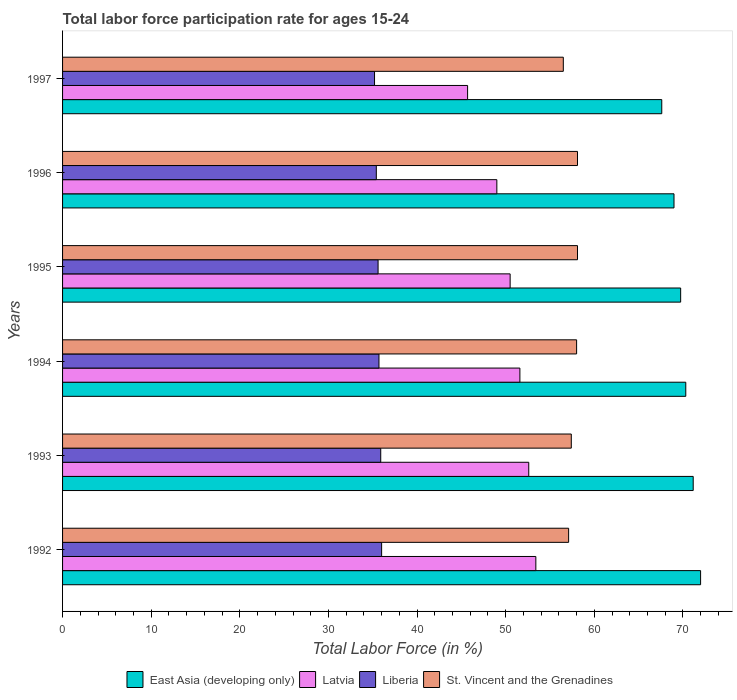How many different coloured bars are there?
Offer a very short reply. 4. How many groups of bars are there?
Keep it short and to the point. 6. Are the number of bars on each tick of the Y-axis equal?
Provide a succinct answer. Yes. What is the labor force participation rate in Liberia in 1994?
Provide a succinct answer. 35.7. Across all years, what is the maximum labor force participation rate in Latvia?
Give a very brief answer. 53.4. Across all years, what is the minimum labor force participation rate in Liberia?
Give a very brief answer. 35.2. In which year was the labor force participation rate in Latvia maximum?
Ensure brevity in your answer.  1992. In which year was the labor force participation rate in Liberia minimum?
Keep it short and to the point. 1997. What is the total labor force participation rate in East Asia (developing only) in the graph?
Keep it short and to the point. 419.8. What is the difference between the labor force participation rate in Latvia in 1994 and that in 1996?
Make the answer very short. 2.6. What is the average labor force participation rate in East Asia (developing only) per year?
Provide a succinct answer. 69.97. In the year 1994, what is the difference between the labor force participation rate in Latvia and labor force participation rate in East Asia (developing only)?
Provide a short and direct response. -18.72. What is the ratio of the labor force participation rate in Liberia in 1993 to that in 1995?
Your response must be concise. 1.01. Is the labor force participation rate in Latvia in 1994 less than that in 1995?
Give a very brief answer. No. Is the difference between the labor force participation rate in Latvia in 1992 and 1996 greater than the difference between the labor force participation rate in East Asia (developing only) in 1992 and 1996?
Keep it short and to the point. Yes. What is the difference between the highest and the second highest labor force participation rate in St. Vincent and the Grenadines?
Your answer should be very brief. 0. What is the difference between the highest and the lowest labor force participation rate in St. Vincent and the Grenadines?
Provide a short and direct response. 1.6. In how many years, is the labor force participation rate in Liberia greater than the average labor force participation rate in Liberia taken over all years?
Your answer should be very brief. 3. Is the sum of the labor force participation rate in Liberia in 1996 and 1997 greater than the maximum labor force participation rate in Latvia across all years?
Give a very brief answer. Yes. What does the 4th bar from the top in 1992 represents?
Give a very brief answer. East Asia (developing only). What does the 3rd bar from the bottom in 1997 represents?
Your response must be concise. Liberia. Is it the case that in every year, the sum of the labor force participation rate in Liberia and labor force participation rate in St. Vincent and the Grenadines is greater than the labor force participation rate in East Asia (developing only)?
Offer a terse response. Yes. How many years are there in the graph?
Your response must be concise. 6. What is the difference between two consecutive major ticks on the X-axis?
Your answer should be compact. 10. Are the values on the major ticks of X-axis written in scientific E-notation?
Make the answer very short. No. Does the graph contain grids?
Your answer should be compact. No. Where does the legend appear in the graph?
Your answer should be very brief. Bottom center. How are the legend labels stacked?
Give a very brief answer. Horizontal. What is the title of the graph?
Ensure brevity in your answer.  Total labor force participation rate for ages 15-24. Does "Bahrain" appear as one of the legend labels in the graph?
Ensure brevity in your answer.  No. What is the label or title of the X-axis?
Your response must be concise. Total Labor Force (in %). What is the Total Labor Force (in %) in East Asia (developing only) in 1992?
Ensure brevity in your answer.  71.99. What is the Total Labor Force (in %) in Latvia in 1992?
Provide a succinct answer. 53.4. What is the Total Labor Force (in %) in Liberia in 1992?
Your response must be concise. 36. What is the Total Labor Force (in %) of St. Vincent and the Grenadines in 1992?
Provide a short and direct response. 57.1. What is the Total Labor Force (in %) in East Asia (developing only) in 1993?
Your answer should be very brief. 71.16. What is the Total Labor Force (in %) in Latvia in 1993?
Your answer should be compact. 52.6. What is the Total Labor Force (in %) of Liberia in 1993?
Your answer should be very brief. 35.9. What is the Total Labor Force (in %) in St. Vincent and the Grenadines in 1993?
Ensure brevity in your answer.  57.4. What is the Total Labor Force (in %) in East Asia (developing only) in 1994?
Make the answer very short. 70.32. What is the Total Labor Force (in %) in Latvia in 1994?
Your response must be concise. 51.6. What is the Total Labor Force (in %) of Liberia in 1994?
Provide a succinct answer. 35.7. What is the Total Labor Force (in %) of St. Vincent and the Grenadines in 1994?
Provide a short and direct response. 58. What is the Total Labor Force (in %) in East Asia (developing only) in 1995?
Your answer should be very brief. 69.74. What is the Total Labor Force (in %) of Latvia in 1995?
Keep it short and to the point. 50.5. What is the Total Labor Force (in %) in Liberia in 1995?
Your response must be concise. 35.6. What is the Total Labor Force (in %) in St. Vincent and the Grenadines in 1995?
Provide a short and direct response. 58.1. What is the Total Labor Force (in %) in East Asia (developing only) in 1996?
Ensure brevity in your answer.  68.99. What is the Total Labor Force (in %) of Liberia in 1996?
Make the answer very short. 35.4. What is the Total Labor Force (in %) in St. Vincent and the Grenadines in 1996?
Make the answer very short. 58.1. What is the Total Labor Force (in %) in East Asia (developing only) in 1997?
Offer a terse response. 67.61. What is the Total Labor Force (in %) of Latvia in 1997?
Make the answer very short. 45.7. What is the Total Labor Force (in %) in Liberia in 1997?
Your answer should be compact. 35.2. What is the Total Labor Force (in %) of St. Vincent and the Grenadines in 1997?
Your answer should be very brief. 56.5. Across all years, what is the maximum Total Labor Force (in %) in East Asia (developing only)?
Provide a short and direct response. 71.99. Across all years, what is the maximum Total Labor Force (in %) of Latvia?
Ensure brevity in your answer.  53.4. Across all years, what is the maximum Total Labor Force (in %) in Liberia?
Your response must be concise. 36. Across all years, what is the maximum Total Labor Force (in %) of St. Vincent and the Grenadines?
Provide a short and direct response. 58.1. Across all years, what is the minimum Total Labor Force (in %) in East Asia (developing only)?
Ensure brevity in your answer.  67.61. Across all years, what is the minimum Total Labor Force (in %) of Latvia?
Your answer should be very brief. 45.7. Across all years, what is the minimum Total Labor Force (in %) of Liberia?
Keep it short and to the point. 35.2. Across all years, what is the minimum Total Labor Force (in %) of St. Vincent and the Grenadines?
Provide a short and direct response. 56.5. What is the total Total Labor Force (in %) in East Asia (developing only) in the graph?
Your answer should be very brief. 419.8. What is the total Total Labor Force (in %) of Latvia in the graph?
Provide a succinct answer. 302.8. What is the total Total Labor Force (in %) of Liberia in the graph?
Offer a terse response. 213.8. What is the total Total Labor Force (in %) of St. Vincent and the Grenadines in the graph?
Give a very brief answer. 345.2. What is the difference between the Total Labor Force (in %) of East Asia (developing only) in 1992 and that in 1993?
Give a very brief answer. 0.83. What is the difference between the Total Labor Force (in %) of Latvia in 1992 and that in 1993?
Offer a terse response. 0.8. What is the difference between the Total Labor Force (in %) of Liberia in 1992 and that in 1993?
Offer a terse response. 0.1. What is the difference between the Total Labor Force (in %) in St. Vincent and the Grenadines in 1992 and that in 1993?
Provide a succinct answer. -0.3. What is the difference between the Total Labor Force (in %) of East Asia (developing only) in 1992 and that in 1994?
Your response must be concise. 1.67. What is the difference between the Total Labor Force (in %) of Liberia in 1992 and that in 1994?
Offer a very short reply. 0.3. What is the difference between the Total Labor Force (in %) in East Asia (developing only) in 1992 and that in 1995?
Provide a short and direct response. 2.25. What is the difference between the Total Labor Force (in %) of Latvia in 1992 and that in 1995?
Keep it short and to the point. 2.9. What is the difference between the Total Labor Force (in %) of East Asia (developing only) in 1992 and that in 1996?
Your answer should be very brief. 3. What is the difference between the Total Labor Force (in %) in Latvia in 1992 and that in 1996?
Your answer should be compact. 4.4. What is the difference between the Total Labor Force (in %) in Liberia in 1992 and that in 1996?
Your response must be concise. 0.6. What is the difference between the Total Labor Force (in %) of St. Vincent and the Grenadines in 1992 and that in 1996?
Provide a short and direct response. -1. What is the difference between the Total Labor Force (in %) in East Asia (developing only) in 1992 and that in 1997?
Provide a short and direct response. 4.38. What is the difference between the Total Labor Force (in %) of East Asia (developing only) in 1993 and that in 1994?
Your answer should be compact. 0.84. What is the difference between the Total Labor Force (in %) of Latvia in 1993 and that in 1994?
Make the answer very short. 1. What is the difference between the Total Labor Force (in %) of Liberia in 1993 and that in 1994?
Provide a short and direct response. 0.2. What is the difference between the Total Labor Force (in %) of East Asia (developing only) in 1993 and that in 1995?
Make the answer very short. 1.42. What is the difference between the Total Labor Force (in %) in Liberia in 1993 and that in 1995?
Offer a very short reply. 0.3. What is the difference between the Total Labor Force (in %) in East Asia (developing only) in 1993 and that in 1996?
Make the answer very short. 2.17. What is the difference between the Total Labor Force (in %) in East Asia (developing only) in 1993 and that in 1997?
Your answer should be very brief. 3.55. What is the difference between the Total Labor Force (in %) in Latvia in 1993 and that in 1997?
Offer a very short reply. 6.9. What is the difference between the Total Labor Force (in %) of East Asia (developing only) in 1994 and that in 1995?
Your answer should be compact. 0.58. What is the difference between the Total Labor Force (in %) in East Asia (developing only) in 1994 and that in 1996?
Provide a short and direct response. 1.33. What is the difference between the Total Labor Force (in %) in Latvia in 1994 and that in 1996?
Provide a succinct answer. 2.6. What is the difference between the Total Labor Force (in %) in Liberia in 1994 and that in 1996?
Your answer should be very brief. 0.3. What is the difference between the Total Labor Force (in %) in East Asia (developing only) in 1994 and that in 1997?
Your answer should be very brief. 2.71. What is the difference between the Total Labor Force (in %) of Latvia in 1994 and that in 1997?
Your answer should be very brief. 5.9. What is the difference between the Total Labor Force (in %) in Liberia in 1994 and that in 1997?
Provide a succinct answer. 0.5. What is the difference between the Total Labor Force (in %) of St. Vincent and the Grenadines in 1994 and that in 1997?
Offer a very short reply. 1.5. What is the difference between the Total Labor Force (in %) of East Asia (developing only) in 1995 and that in 1996?
Your answer should be compact. 0.75. What is the difference between the Total Labor Force (in %) in Liberia in 1995 and that in 1996?
Your answer should be very brief. 0.2. What is the difference between the Total Labor Force (in %) of St. Vincent and the Grenadines in 1995 and that in 1996?
Provide a short and direct response. 0. What is the difference between the Total Labor Force (in %) in East Asia (developing only) in 1995 and that in 1997?
Provide a succinct answer. 2.13. What is the difference between the Total Labor Force (in %) of Liberia in 1995 and that in 1997?
Your response must be concise. 0.4. What is the difference between the Total Labor Force (in %) in East Asia (developing only) in 1996 and that in 1997?
Ensure brevity in your answer.  1.38. What is the difference between the Total Labor Force (in %) of Latvia in 1996 and that in 1997?
Ensure brevity in your answer.  3.3. What is the difference between the Total Labor Force (in %) in St. Vincent and the Grenadines in 1996 and that in 1997?
Make the answer very short. 1.6. What is the difference between the Total Labor Force (in %) of East Asia (developing only) in 1992 and the Total Labor Force (in %) of Latvia in 1993?
Your response must be concise. 19.39. What is the difference between the Total Labor Force (in %) in East Asia (developing only) in 1992 and the Total Labor Force (in %) in Liberia in 1993?
Keep it short and to the point. 36.09. What is the difference between the Total Labor Force (in %) in East Asia (developing only) in 1992 and the Total Labor Force (in %) in St. Vincent and the Grenadines in 1993?
Provide a succinct answer. 14.59. What is the difference between the Total Labor Force (in %) of Liberia in 1992 and the Total Labor Force (in %) of St. Vincent and the Grenadines in 1993?
Give a very brief answer. -21.4. What is the difference between the Total Labor Force (in %) in East Asia (developing only) in 1992 and the Total Labor Force (in %) in Latvia in 1994?
Provide a short and direct response. 20.39. What is the difference between the Total Labor Force (in %) in East Asia (developing only) in 1992 and the Total Labor Force (in %) in Liberia in 1994?
Your answer should be compact. 36.29. What is the difference between the Total Labor Force (in %) of East Asia (developing only) in 1992 and the Total Labor Force (in %) of St. Vincent and the Grenadines in 1994?
Ensure brevity in your answer.  13.99. What is the difference between the Total Labor Force (in %) in Latvia in 1992 and the Total Labor Force (in %) in Liberia in 1994?
Give a very brief answer. 17.7. What is the difference between the Total Labor Force (in %) of Latvia in 1992 and the Total Labor Force (in %) of St. Vincent and the Grenadines in 1994?
Keep it short and to the point. -4.6. What is the difference between the Total Labor Force (in %) in Liberia in 1992 and the Total Labor Force (in %) in St. Vincent and the Grenadines in 1994?
Your answer should be very brief. -22. What is the difference between the Total Labor Force (in %) of East Asia (developing only) in 1992 and the Total Labor Force (in %) of Latvia in 1995?
Give a very brief answer. 21.49. What is the difference between the Total Labor Force (in %) in East Asia (developing only) in 1992 and the Total Labor Force (in %) in Liberia in 1995?
Provide a succinct answer. 36.39. What is the difference between the Total Labor Force (in %) of East Asia (developing only) in 1992 and the Total Labor Force (in %) of St. Vincent and the Grenadines in 1995?
Offer a very short reply. 13.89. What is the difference between the Total Labor Force (in %) of Liberia in 1992 and the Total Labor Force (in %) of St. Vincent and the Grenadines in 1995?
Your answer should be very brief. -22.1. What is the difference between the Total Labor Force (in %) of East Asia (developing only) in 1992 and the Total Labor Force (in %) of Latvia in 1996?
Make the answer very short. 22.99. What is the difference between the Total Labor Force (in %) in East Asia (developing only) in 1992 and the Total Labor Force (in %) in Liberia in 1996?
Your response must be concise. 36.59. What is the difference between the Total Labor Force (in %) of East Asia (developing only) in 1992 and the Total Labor Force (in %) of St. Vincent and the Grenadines in 1996?
Ensure brevity in your answer.  13.89. What is the difference between the Total Labor Force (in %) in Liberia in 1992 and the Total Labor Force (in %) in St. Vincent and the Grenadines in 1996?
Your answer should be compact. -22.1. What is the difference between the Total Labor Force (in %) in East Asia (developing only) in 1992 and the Total Labor Force (in %) in Latvia in 1997?
Your answer should be very brief. 26.29. What is the difference between the Total Labor Force (in %) of East Asia (developing only) in 1992 and the Total Labor Force (in %) of Liberia in 1997?
Give a very brief answer. 36.79. What is the difference between the Total Labor Force (in %) of East Asia (developing only) in 1992 and the Total Labor Force (in %) of St. Vincent and the Grenadines in 1997?
Your answer should be very brief. 15.49. What is the difference between the Total Labor Force (in %) of Latvia in 1992 and the Total Labor Force (in %) of St. Vincent and the Grenadines in 1997?
Your answer should be very brief. -3.1. What is the difference between the Total Labor Force (in %) in Liberia in 1992 and the Total Labor Force (in %) in St. Vincent and the Grenadines in 1997?
Keep it short and to the point. -20.5. What is the difference between the Total Labor Force (in %) of East Asia (developing only) in 1993 and the Total Labor Force (in %) of Latvia in 1994?
Your response must be concise. 19.56. What is the difference between the Total Labor Force (in %) in East Asia (developing only) in 1993 and the Total Labor Force (in %) in Liberia in 1994?
Your answer should be very brief. 35.46. What is the difference between the Total Labor Force (in %) in East Asia (developing only) in 1993 and the Total Labor Force (in %) in St. Vincent and the Grenadines in 1994?
Your answer should be very brief. 13.16. What is the difference between the Total Labor Force (in %) of Latvia in 1993 and the Total Labor Force (in %) of Liberia in 1994?
Offer a very short reply. 16.9. What is the difference between the Total Labor Force (in %) of Latvia in 1993 and the Total Labor Force (in %) of St. Vincent and the Grenadines in 1994?
Ensure brevity in your answer.  -5.4. What is the difference between the Total Labor Force (in %) in Liberia in 1993 and the Total Labor Force (in %) in St. Vincent and the Grenadines in 1994?
Your response must be concise. -22.1. What is the difference between the Total Labor Force (in %) of East Asia (developing only) in 1993 and the Total Labor Force (in %) of Latvia in 1995?
Your response must be concise. 20.66. What is the difference between the Total Labor Force (in %) of East Asia (developing only) in 1993 and the Total Labor Force (in %) of Liberia in 1995?
Offer a terse response. 35.56. What is the difference between the Total Labor Force (in %) in East Asia (developing only) in 1993 and the Total Labor Force (in %) in St. Vincent and the Grenadines in 1995?
Give a very brief answer. 13.06. What is the difference between the Total Labor Force (in %) in Latvia in 1993 and the Total Labor Force (in %) in St. Vincent and the Grenadines in 1995?
Provide a short and direct response. -5.5. What is the difference between the Total Labor Force (in %) in Liberia in 1993 and the Total Labor Force (in %) in St. Vincent and the Grenadines in 1995?
Keep it short and to the point. -22.2. What is the difference between the Total Labor Force (in %) of East Asia (developing only) in 1993 and the Total Labor Force (in %) of Latvia in 1996?
Your answer should be compact. 22.16. What is the difference between the Total Labor Force (in %) of East Asia (developing only) in 1993 and the Total Labor Force (in %) of Liberia in 1996?
Give a very brief answer. 35.76. What is the difference between the Total Labor Force (in %) of East Asia (developing only) in 1993 and the Total Labor Force (in %) of St. Vincent and the Grenadines in 1996?
Offer a terse response. 13.06. What is the difference between the Total Labor Force (in %) in Latvia in 1993 and the Total Labor Force (in %) in Liberia in 1996?
Offer a very short reply. 17.2. What is the difference between the Total Labor Force (in %) of Latvia in 1993 and the Total Labor Force (in %) of St. Vincent and the Grenadines in 1996?
Keep it short and to the point. -5.5. What is the difference between the Total Labor Force (in %) of Liberia in 1993 and the Total Labor Force (in %) of St. Vincent and the Grenadines in 1996?
Ensure brevity in your answer.  -22.2. What is the difference between the Total Labor Force (in %) in East Asia (developing only) in 1993 and the Total Labor Force (in %) in Latvia in 1997?
Offer a terse response. 25.46. What is the difference between the Total Labor Force (in %) in East Asia (developing only) in 1993 and the Total Labor Force (in %) in Liberia in 1997?
Your answer should be very brief. 35.96. What is the difference between the Total Labor Force (in %) in East Asia (developing only) in 1993 and the Total Labor Force (in %) in St. Vincent and the Grenadines in 1997?
Your answer should be compact. 14.66. What is the difference between the Total Labor Force (in %) in Latvia in 1993 and the Total Labor Force (in %) in Liberia in 1997?
Give a very brief answer. 17.4. What is the difference between the Total Labor Force (in %) of Latvia in 1993 and the Total Labor Force (in %) of St. Vincent and the Grenadines in 1997?
Offer a very short reply. -3.9. What is the difference between the Total Labor Force (in %) in Liberia in 1993 and the Total Labor Force (in %) in St. Vincent and the Grenadines in 1997?
Offer a very short reply. -20.6. What is the difference between the Total Labor Force (in %) in East Asia (developing only) in 1994 and the Total Labor Force (in %) in Latvia in 1995?
Your answer should be compact. 19.82. What is the difference between the Total Labor Force (in %) in East Asia (developing only) in 1994 and the Total Labor Force (in %) in Liberia in 1995?
Keep it short and to the point. 34.72. What is the difference between the Total Labor Force (in %) in East Asia (developing only) in 1994 and the Total Labor Force (in %) in St. Vincent and the Grenadines in 1995?
Offer a very short reply. 12.22. What is the difference between the Total Labor Force (in %) in Latvia in 1994 and the Total Labor Force (in %) in Liberia in 1995?
Provide a short and direct response. 16. What is the difference between the Total Labor Force (in %) in Latvia in 1994 and the Total Labor Force (in %) in St. Vincent and the Grenadines in 1995?
Keep it short and to the point. -6.5. What is the difference between the Total Labor Force (in %) in Liberia in 1994 and the Total Labor Force (in %) in St. Vincent and the Grenadines in 1995?
Give a very brief answer. -22.4. What is the difference between the Total Labor Force (in %) in East Asia (developing only) in 1994 and the Total Labor Force (in %) in Latvia in 1996?
Your answer should be very brief. 21.32. What is the difference between the Total Labor Force (in %) in East Asia (developing only) in 1994 and the Total Labor Force (in %) in Liberia in 1996?
Your response must be concise. 34.92. What is the difference between the Total Labor Force (in %) in East Asia (developing only) in 1994 and the Total Labor Force (in %) in St. Vincent and the Grenadines in 1996?
Your answer should be compact. 12.22. What is the difference between the Total Labor Force (in %) of Latvia in 1994 and the Total Labor Force (in %) of Liberia in 1996?
Offer a very short reply. 16.2. What is the difference between the Total Labor Force (in %) in Latvia in 1994 and the Total Labor Force (in %) in St. Vincent and the Grenadines in 1996?
Provide a short and direct response. -6.5. What is the difference between the Total Labor Force (in %) in Liberia in 1994 and the Total Labor Force (in %) in St. Vincent and the Grenadines in 1996?
Provide a short and direct response. -22.4. What is the difference between the Total Labor Force (in %) of East Asia (developing only) in 1994 and the Total Labor Force (in %) of Latvia in 1997?
Make the answer very short. 24.62. What is the difference between the Total Labor Force (in %) in East Asia (developing only) in 1994 and the Total Labor Force (in %) in Liberia in 1997?
Your response must be concise. 35.12. What is the difference between the Total Labor Force (in %) of East Asia (developing only) in 1994 and the Total Labor Force (in %) of St. Vincent and the Grenadines in 1997?
Provide a succinct answer. 13.82. What is the difference between the Total Labor Force (in %) of Latvia in 1994 and the Total Labor Force (in %) of Liberia in 1997?
Give a very brief answer. 16.4. What is the difference between the Total Labor Force (in %) in Liberia in 1994 and the Total Labor Force (in %) in St. Vincent and the Grenadines in 1997?
Make the answer very short. -20.8. What is the difference between the Total Labor Force (in %) in East Asia (developing only) in 1995 and the Total Labor Force (in %) in Latvia in 1996?
Provide a short and direct response. 20.74. What is the difference between the Total Labor Force (in %) of East Asia (developing only) in 1995 and the Total Labor Force (in %) of Liberia in 1996?
Your answer should be compact. 34.34. What is the difference between the Total Labor Force (in %) of East Asia (developing only) in 1995 and the Total Labor Force (in %) of St. Vincent and the Grenadines in 1996?
Give a very brief answer. 11.64. What is the difference between the Total Labor Force (in %) in Latvia in 1995 and the Total Labor Force (in %) in St. Vincent and the Grenadines in 1996?
Your response must be concise. -7.6. What is the difference between the Total Labor Force (in %) of Liberia in 1995 and the Total Labor Force (in %) of St. Vincent and the Grenadines in 1996?
Provide a short and direct response. -22.5. What is the difference between the Total Labor Force (in %) in East Asia (developing only) in 1995 and the Total Labor Force (in %) in Latvia in 1997?
Provide a succinct answer. 24.04. What is the difference between the Total Labor Force (in %) in East Asia (developing only) in 1995 and the Total Labor Force (in %) in Liberia in 1997?
Provide a short and direct response. 34.54. What is the difference between the Total Labor Force (in %) in East Asia (developing only) in 1995 and the Total Labor Force (in %) in St. Vincent and the Grenadines in 1997?
Ensure brevity in your answer.  13.24. What is the difference between the Total Labor Force (in %) of Latvia in 1995 and the Total Labor Force (in %) of St. Vincent and the Grenadines in 1997?
Ensure brevity in your answer.  -6. What is the difference between the Total Labor Force (in %) in Liberia in 1995 and the Total Labor Force (in %) in St. Vincent and the Grenadines in 1997?
Offer a terse response. -20.9. What is the difference between the Total Labor Force (in %) in East Asia (developing only) in 1996 and the Total Labor Force (in %) in Latvia in 1997?
Keep it short and to the point. 23.29. What is the difference between the Total Labor Force (in %) in East Asia (developing only) in 1996 and the Total Labor Force (in %) in Liberia in 1997?
Offer a very short reply. 33.79. What is the difference between the Total Labor Force (in %) in East Asia (developing only) in 1996 and the Total Labor Force (in %) in St. Vincent and the Grenadines in 1997?
Make the answer very short. 12.49. What is the difference between the Total Labor Force (in %) in Latvia in 1996 and the Total Labor Force (in %) in Liberia in 1997?
Provide a short and direct response. 13.8. What is the difference between the Total Labor Force (in %) of Latvia in 1996 and the Total Labor Force (in %) of St. Vincent and the Grenadines in 1997?
Your response must be concise. -7.5. What is the difference between the Total Labor Force (in %) of Liberia in 1996 and the Total Labor Force (in %) of St. Vincent and the Grenadines in 1997?
Provide a short and direct response. -21.1. What is the average Total Labor Force (in %) in East Asia (developing only) per year?
Your answer should be compact. 69.97. What is the average Total Labor Force (in %) in Latvia per year?
Your response must be concise. 50.47. What is the average Total Labor Force (in %) of Liberia per year?
Offer a very short reply. 35.63. What is the average Total Labor Force (in %) of St. Vincent and the Grenadines per year?
Keep it short and to the point. 57.53. In the year 1992, what is the difference between the Total Labor Force (in %) in East Asia (developing only) and Total Labor Force (in %) in Latvia?
Provide a short and direct response. 18.59. In the year 1992, what is the difference between the Total Labor Force (in %) of East Asia (developing only) and Total Labor Force (in %) of Liberia?
Offer a terse response. 35.99. In the year 1992, what is the difference between the Total Labor Force (in %) in East Asia (developing only) and Total Labor Force (in %) in St. Vincent and the Grenadines?
Provide a short and direct response. 14.89. In the year 1992, what is the difference between the Total Labor Force (in %) in Latvia and Total Labor Force (in %) in Liberia?
Your response must be concise. 17.4. In the year 1992, what is the difference between the Total Labor Force (in %) of Liberia and Total Labor Force (in %) of St. Vincent and the Grenadines?
Keep it short and to the point. -21.1. In the year 1993, what is the difference between the Total Labor Force (in %) of East Asia (developing only) and Total Labor Force (in %) of Latvia?
Make the answer very short. 18.56. In the year 1993, what is the difference between the Total Labor Force (in %) of East Asia (developing only) and Total Labor Force (in %) of Liberia?
Keep it short and to the point. 35.26. In the year 1993, what is the difference between the Total Labor Force (in %) of East Asia (developing only) and Total Labor Force (in %) of St. Vincent and the Grenadines?
Your response must be concise. 13.76. In the year 1993, what is the difference between the Total Labor Force (in %) of Latvia and Total Labor Force (in %) of Liberia?
Keep it short and to the point. 16.7. In the year 1993, what is the difference between the Total Labor Force (in %) in Liberia and Total Labor Force (in %) in St. Vincent and the Grenadines?
Provide a short and direct response. -21.5. In the year 1994, what is the difference between the Total Labor Force (in %) of East Asia (developing only) and Total Labor Force (in %) of Latvia?
Make the answer very short. 18.72. In the year 1994, what is the difference between the Total Labor Force (in %) of East Asia (developing only) and Total Labor Force (in %) of Liberia?
Give a very brief answer. 34.62. In the year 1994, what is the difference between the Total Labor Force (in %) in East Asia (developing only) and Total Labor Force (in %) in St. Vincent and the Grenadines?
Make the answer very short. 12.32. In the year 1994, what is the difference between the Total Labor Force (in %) in Latvia and Total Labor Force (in %) in St. Vincent and the Grenadines?
Give a very brief answer. -6.4. In the year 1994, what is the difference between the Total Labor Force (in %) of Liberia and Total Labor Force (in %) of St. Vincent and the Grenadines?
Provide a short and direct response. -22.3. In the year 1995, what is the difference between the Total Labor Force (in %) of East Asia (developing only) and Total Labor Force (in %) of Latvia?
Ensure brevity in your answer.  19.24. In the year 1995, what is the difference between the Total Labor Force (in %) in East Asia (developing only) and Total Labor Force (in %) in Liberia?
Your answer should be compact. 34.14. In the year 1995, what is the difference between the Total Labor Force (in %) in East Asia (developing only) and Total Labor Force (in %) in St. Vincent and the Grenadines?
Make the answer very short. 11.64. In the year 1995, what is the difference between the Total Labor Force (in %) in Latvia and Total Labor Force (in %) in St. Vincent and the Grenadines?
Provide a succinct answer. -7.6. In the year 1995, what is the difference between the Total Labor Force (in %) in Liberia and Total Labor Force (in %) in St. Vincent and the Grenadines?
Provide a short and direct response. -22.5. In the year 1996, what is the difference between the Total Labor Force (in %) of East Asia (developing only) and Total Labor Force (in %) of Latvia?
Offer a very short reply. 19.99. In the year 1996, what is the difference between the Total Labor Force (in %) of East Asia (developing only) and Total Labor Force (in %) of Liberia?
Your answer should be compact. 33.59. In the year 1996, what is the difference between the Total Labor Force (in %) of East Asia (developing only) and Total Labor Force (in %) of St. Vincent and the Grenadines?
Your response must be concise. 10.89. In the year 1996, what is the difference between the Total Labor Force (in %) of Liberia and Total Labor Force (in %) of St. Vincent and the Grenadines?
Give a very brief answer. -22.7. In the year 1997, what is the difference between the Total Labor Force (in %) in East Asia (developing only) and Total Labor Force (in %) in Latvia?
Offer a terse response. 21.91. In the year 1997, what is the difference between the Total Labor Force (in %) of East Asia (developing only) and Total Labor Force (in %) of Liberia?
Make the answer very short. 32.41. In the year 1997, what is the difference between the Total Labor Force (in %) of East Asia (developing only) and Total Labor Force (in %) of St. Vincent and the Grenadines?
Provide a short and direct response. 11.11. In the year 1997, what is the difference between the Total Labor Force (in %) in Latvia and Total Labor Force (in %) in Liberia?
Your answer should be very brief. 10.5. In the year 1997, what is the difference between the Total Labor Force (in %) in Liberia and Total Labor Force (in %) in St. Vincent and the Grenadines?
Your answer should be very brief. -21.3. What is the ratio of the Total Labor Force (in %) of East Asia (developing only) in 1992 to that in 1993?
Keep it short and to the point. 1.01. What is the ratio of the Total Labor Force (in %) of Latvia in 1992 to that in 1993?
Provide a succinct answer. 1.02. What is the ratio of the Total Labor Force (in %) in Liberia in 1992 to that in 1993?
Give a very brief answer. 1. What is the ratio of the Total Labor Force (in %) in St. Vincent and the Grenadines in 1992 to that in 1993?
Keep it short and to the point. 0.99. What is the ratio of the Total Labor Force (in %) in East Asia (developing only) in 1992 to that in 1994?
Offer a terse response. 1.02. What is the ratio of the Total Labor Force (in %) in Latvia in 1992 to that in 1994?
Provide a short and direct response. 1.03. What is the ratio of the Total Labor Force (in %) of Liberia in 1992 to that in 1994?
Make the answer very short. 1.01. What is the ratio of the Total Labor Force (in %) of St. Vincent and the Grenadines in 1992 to that in 1994?
Make the answer very short. 0.98. What is the ratio of the Total Labor Force (in %) of East Asia (developing only) in 1992 to that in 1995?
Your answer should be very brief. 1.03. What is the ratio of the Total Labor Force (in %) of Latvia in 1992 to that in 1995?
Keep it short and to the point. 1.06. What is the ratio of the Total Labor Force (in %) of Liberia in 1992 to that in 1995?
Make the answer very short. 1.01. What is the ratio of the Total Labor Force (in %) of St. Vincent and the Grenadines in 1992 to that in 1995?
Your response must be concise. 0.98. What is the ratio of the Total Labor Force (in %) in East Asia (developing only) in 1992 to that in 1996?
Ensure brevity in your answer.  1.04. What is the ratio of the Total Labor Force (in %) of Latvia in 1992 to that in 1996?
Your answer should be compact. 1.09. What is the ratio of the Total Labor Force (in %) of Liberia in 1992 to that in 1996?
Offer a terse response. 1.02. What is the ratio of the Total Labor Force (in %) in St. Vincent and the Grenadines in 1992 to that in 1996?
Provide a short and direct response. 0.98. What is the ratio of the Total Labor Force (in %) of East Asia (developing only) in 1992 to that in 1997?
Your response must be concise. 1.06. What is the ratio of the Total Labor Force (in %) in Latvia in 1992 to that in 1997?
Offer a terse response. 1.17. What is the ratio of the Total Labor Force (in %) of Liberia in 1992 to that in 1997?
Provide a short and direct response. 1.02. What is the ratio of the Total Labor Force (in %) of St. Vincent and the Grenadines in 1992 to that in 1997?
Your answer should be very brief. 1.01. What is the ratio of the Total Labor Force (in %) in East Asia (developing only) in 1993 to that in 1994?
Your answer should be compact. 1.01. What is the ratio of the Total Labor Force (in %) of Latvia in 1993 to that in 1994?
Your response must be concise. 1.02. What is the ratio of the Total Labor Force (in %) of Liberia in 1993 to that in 1994?
Your answer should be very brief. 1.01. What is the ratio of the Total Labor Force (in %) of St. Vincent and the Grenadines in 1993 to that in 1994?
Your answer should be very brief. 0.99. What is the ratio of the Total Labor Force (in %) of East Asia (developing only) in 1993 to that in 1995?
Your answer should be very brief. 1.02. What is the ratio of the Total Labor Force (in %) in Latvia in 1993 to that in 1995?
Keep it short and to the point. 1.04. What is the ratio of the Total Labor Force (in %) of Liberia in 1993 to that in 1995?
Keep it short and to the point. 1.01. What is the ratio of the Total Labor Force (in %) in East Asia (developing only) in 1993 to that in 1996?
Provide a succinct answer. 1.03. What is the ratio of the Total Labor Force (in %) in Latvia in 1993 to that in 1996?
Your answer should be very brief. 1.07. What is the ratio of the Total Labor Force (in %) in Liberia in 1993 to that in 1996?
Ensure brevity in your answer.  1.01. What is the ratio of the Total Labor Force (in %) in St. Vincent and the Grenadines in 1993 to that in 1996?
Ensure brevity in your answer.  0.99. What is the ratio of the Total Labor Force (in %) in East Asia (developing only) in 1993 to that in 1997?
Offer a terse response. 1.05. What is the ratio of the Total Labor Force (in %) of Latvia in 1993 to that in 1997?
Provide a short and direct response. 1.15. What is the ratio of the Total Labor Force (in %) in Liberia in 1993 to that in 1997?
Your answer should be compact. 1.02. What is the ratio of the Total Labor Force (in %) of St. Vincent and the Grenadines in 1993 to that in 1997?
Your answer should be very brief. 1.02. What is the ratio of the Total Labor Force (in %) of East Asia (developing only) in 1994 to that in 1995?
Your answer should be very brief. 1.01. What is the ratio of the Total Labor Force (in %) in Latvia in 1994 to that in 1995?
Keep it short and to the point. 1.02. What is the ratio of the Total Labor Force (in %) in East Asia (developing only) in 1994 to that in 1996?
Offer a terse response. 1.02. What is the ratio of the Total Labor Force (in %) of Latvia in 1994 to that in 1996?
Keep it short and to the point. 1.05. What is the ratio of the Total Labor Force (in %) of Liberia in 1994 to that in 1996?
Your answer should be compact. 1.01. What is the ratio of the Total Labor Force (in %) in East Asia (developing only) in 1994 to that in 1997?
Make the answer very short. 1.04. What is the ratio of the Total Labor Force (in %) of Latvia in 1994 to that in 1997?
Keep it short and to the point. 1.13. What is the ratio of the Total Labor Force (in %) of Liberia in 1994 to that in 1997?
Your answer should be very brief. 1.01. What is the ratio of the Total Labor Force (in %) of St. Vincent and the Grenadines in 1994 to that in 1997?
Your answer should be very brief. 1.03. What is the ratio of the Total Labor Force (in %) in East Asia (developing only) in 1995 to that in 1996?
Provide a succinct answer. 1.01. What is the ratio of the Total Labor Force (in %) in Latvia in 1995 to that in 1996?
Provide a short and direct response. 1.03. What is the ratio of the Total Labor Force (in %) in Liberia in 1995 to that in 1996?
Your response must be concise. 1.01. What is the ratio of the Total Labor Force (in %) of St. Vincent and the Grenadines in 1995 to that in 1996?
Provide a short and direct response. 1. What is the ratio of the Total Labor Force (in %) of East Asia (developing only) in 1995 to that in 1997?
Your response must be concise. 1.03. What is the ratio of the Total Labor Force (in %) in Latvia in 1995 to that in 1997?
Offer a terse response. 1.1. What is the ratio of the Total Labor Force (in %) in Liberia in 1995 to that in 1997?
Ensure brevity in your answer.  1.01. What is the ratio of the Total Labor Force (in %) in St. Vincent and the Grenadines in 1995 to that in 1997?
Provide a short and direct response. 1.03. What is the ratio of the Total Labor Force (in %) in East Asia (developing only) in 1996 to that in 1997?
Keep it short and to the point. 1.02. What is the ratio of the Total Labor Force (in %) in Latvia in 1996 to that in 1997?
Your answer should be very brief. 1.07. What is the ratio of the Total Labor Force (in %) of St. Vincent and the Grenadines in 1996 to that in 1997?
Your response must be concise. 1.03. What is the difference between the highest and the second highest Total Labor Force (in %) of East Asia (developing only)?
Make the answer very short. 0.83. What is the difference between the highest and the second highest Total Labor Force (in %) of Latvia?
Provide a succinct answer. 0.8. What is the difference between the highest and the second highest Total Labor Force (in %) of Liberia?
Keep it short and to the point. 0.1. What is the difference between the highest and the second highest Total Labor Force (in %) of St. Vincent and the Grenadines?
Give a very brief answer. 0. What is the difference between the highest and the lowest Total Labor Force (in %) of East Asia (developing only)?
Make the answer very short. 4.38. What is the difference between the highest and the lowest Total Labor Force (in %) of Liberia?
Provide a short and direct response. 0.8. What is the difference between the highest and the lowest Total Labor Force (in %) in St. Vincent and the Grenadines?
Your response must be concise. 1.6. 